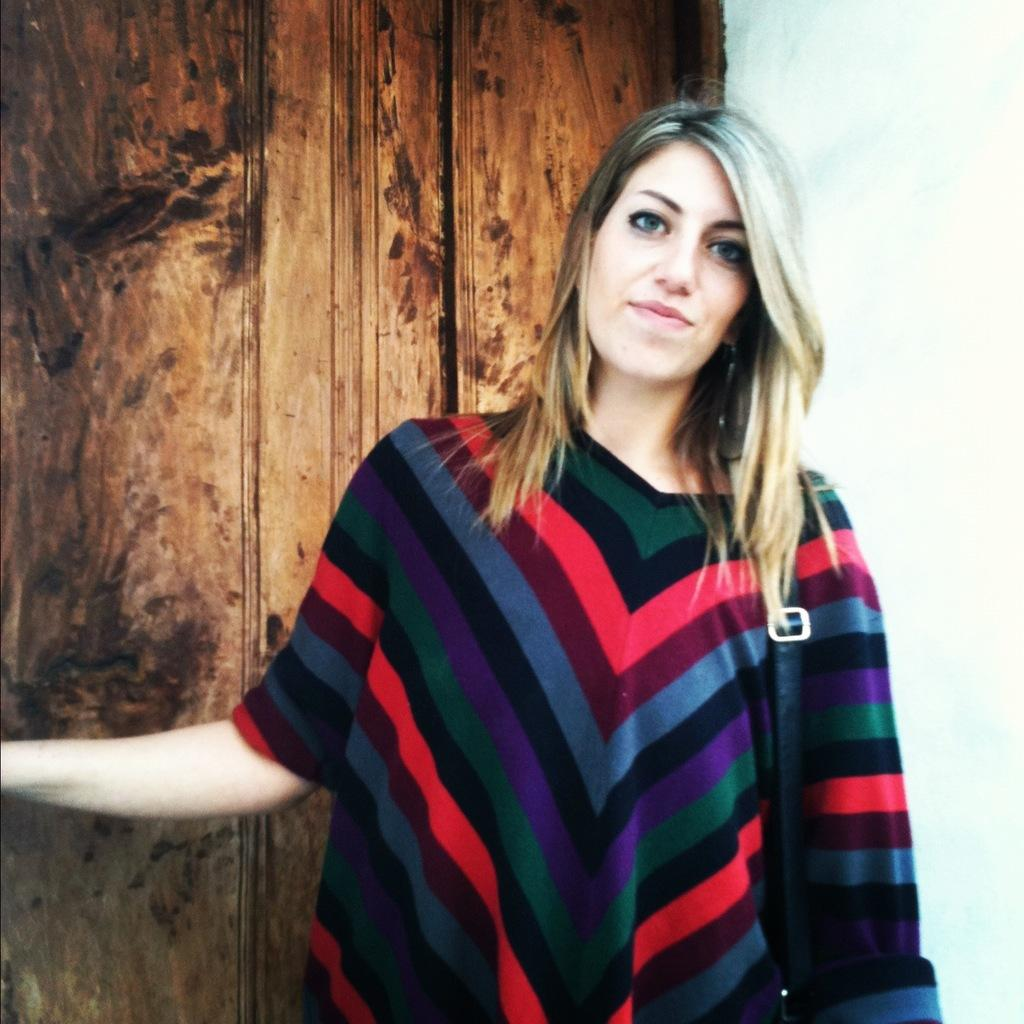Who is present in the image? There is a woman in the image. What is the woman doing in the image? The woman is watching and smiling. What can be seen in the background of the image? There is a wooden object and a white wall in the background of the image. How does the woman burn the wooden object in the image? There is no indication in the image that the woman is burning anything, and there is no wooden object being burned. 